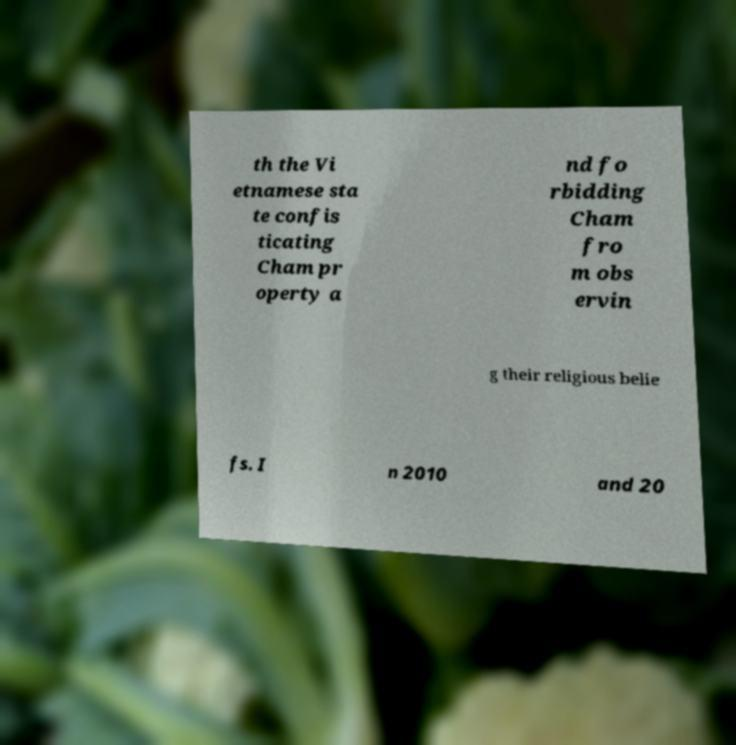What messages or text are displayed in this image? I need them in a readable, typed format. th the Vi etnamese sta te confis ticating Cham pr operty a nd fo rbidding Cham fro m obs ervin g their religious belie fs. I n 2010 and 20 